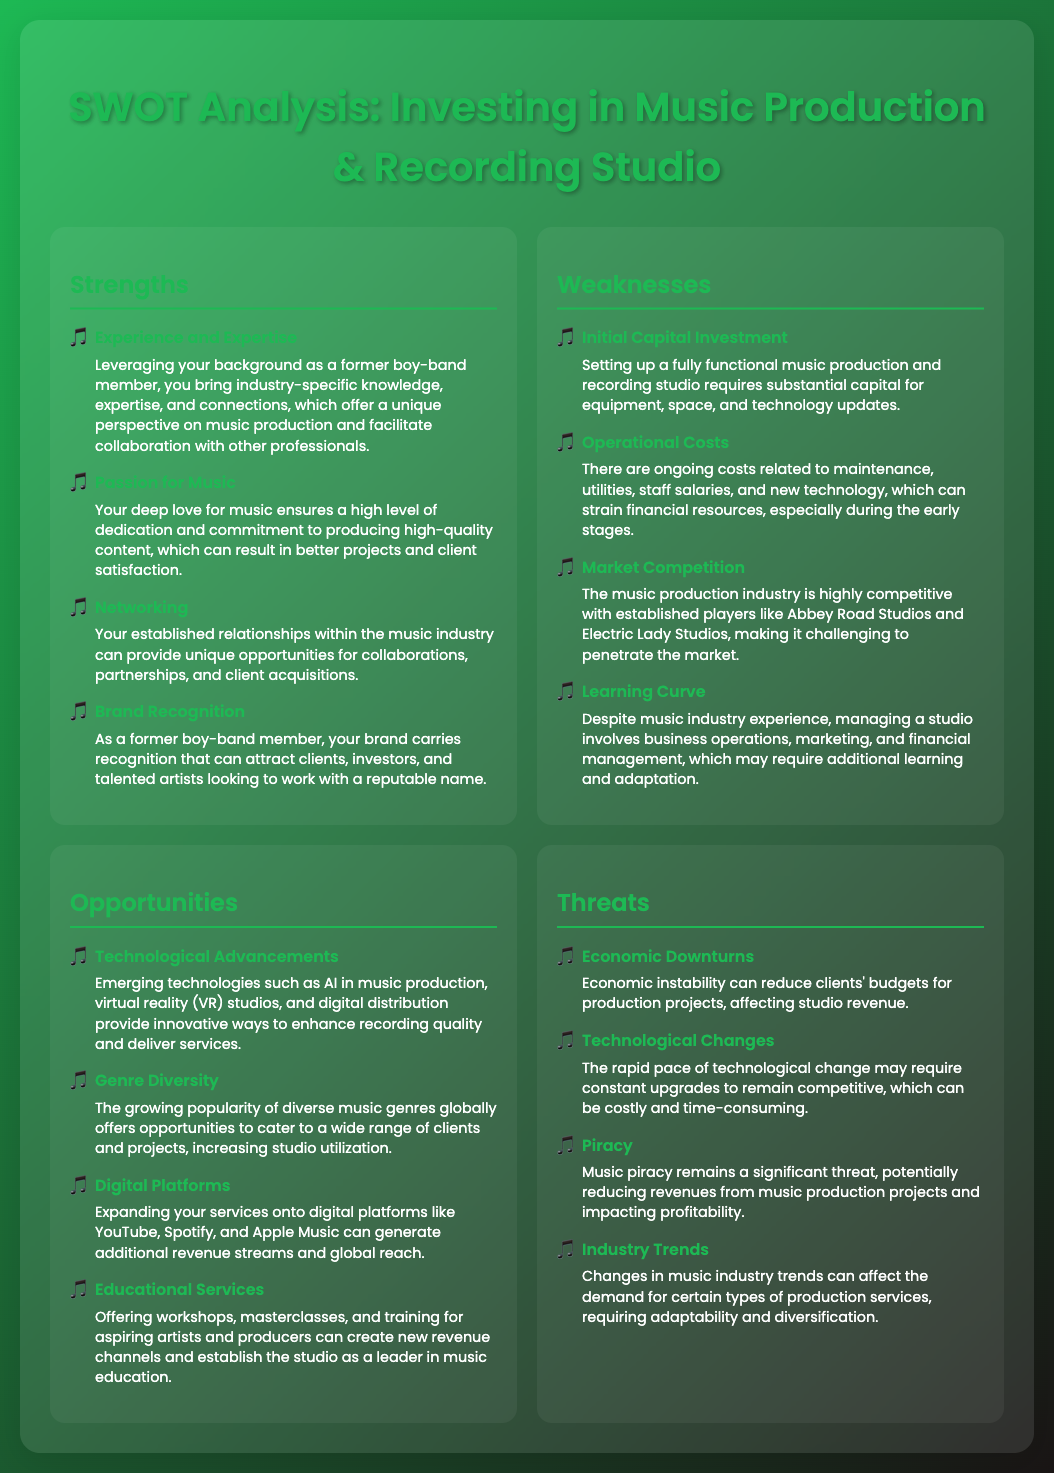what is a strength related to expertise? One of the strengths mentioned is "Experience and Expertise," highlighting industry-specific knowledge and connections.
Answer: Experience and Expertise what is a key weakness due to financial reasons? The document mentions "Initial Capital Investment" as a financial-related weakness for setting up a studio.
Answer: Initial Capital Investment what opportunity can enhance recording quality? The opportunity "Technological Advancements" refers to emerging technologies that improve recording quality.
Answer: Technological Advancements what type of services can create new revenue channels? The "Educational Services" aspect mentions offering workshops and masterclasses as a way to create new revenue channels.
Answer: Educational Services what is a major threat related to music consumption? "Piracy" is mentioned as a significant threat that can reduce revenues from production projects.
Answer: Piracy how can your established relationships benefit you? The aspect "Networking" emphasizes that established relationships can lead to collaborations and client acquisitions.
Answer: Networking what is a strength that reflects your dedication? "Passion for Music" is a strength indicating a high level of dedication to producing high-quality content.
Answer: Passion for Music what is a factor due to competition in the market? "Market Competition" is a weakness highlighting the challenge of penetrating a competitive industry.
Answer: Market Competition how can you utilize the growing popularity of music genres? The "Genre Diversity" opportunity allows catering to a wide range of clients and projects due to the popularity of diverse genres.
Answer: Genre Diversity 